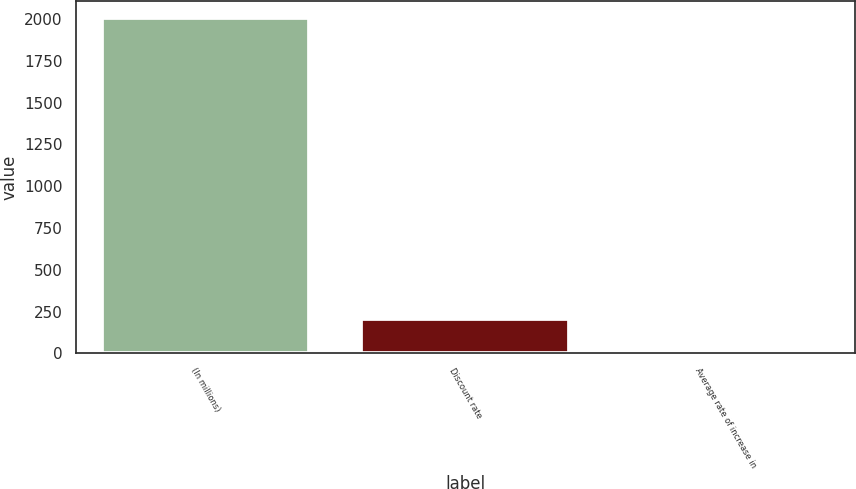<chart> <loc_0><loc_0><loc_500><loc_500><bar_chart><fcel>(In millions)<fcel>Discount rate<fcel>Average rate of increase in<nl><fcel>2009<fcel>204.5<fcel>4<nl></chart> 